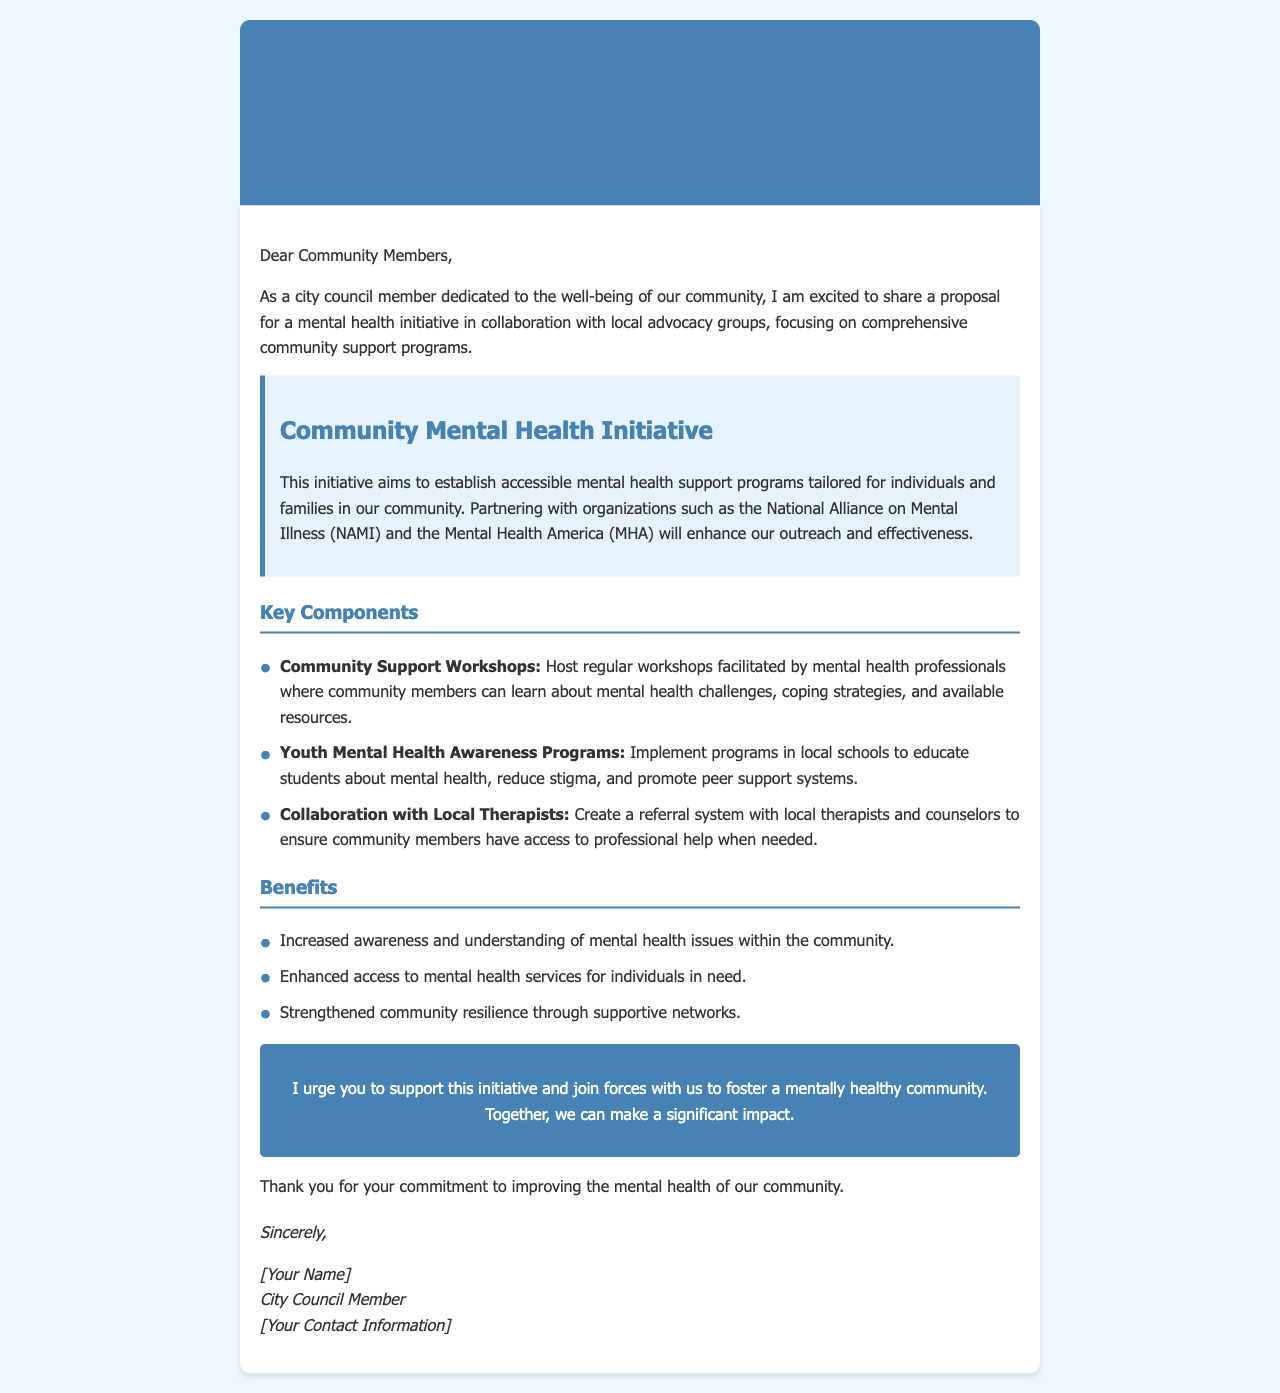What is the title of the proposal? The title of the proposal is stated at the beginning of the document.
Answer: Proposal for Mental Health Initiative Collaboration Who are the primary organizations mentioned in the initiative? The organizations mentioned in the document are key partners in the initiative.
Answer: National Alliance on Mental Illness (NAMI) and Mental Health America (MHA) What is one key component of the initiative? The key components listed are specific activities that make up the initiative.
Answer: Community Support Workshops How many benefits are listed in the document? The number of benefits can be found in the corresponding section.
Answer: Three What is the main goal of the Community Mental Health Initiative? The goal of the initiative is summarized in the proposal summary section of the document.
Answer: Establish accessible mental health support programs What does the proposal urge community members to do? The document contains a call to action encouraging specific community involvement.
Answer: Support this initiative Who wrote the proposal? The author of the proposal is mentioned in the closing signature of the document.
Answer: [Your Name] In what context is mental health education proposed for youth? The context can be derived from the purpose of the youth programs mentioned.
Answer: Implement programs in local schools 